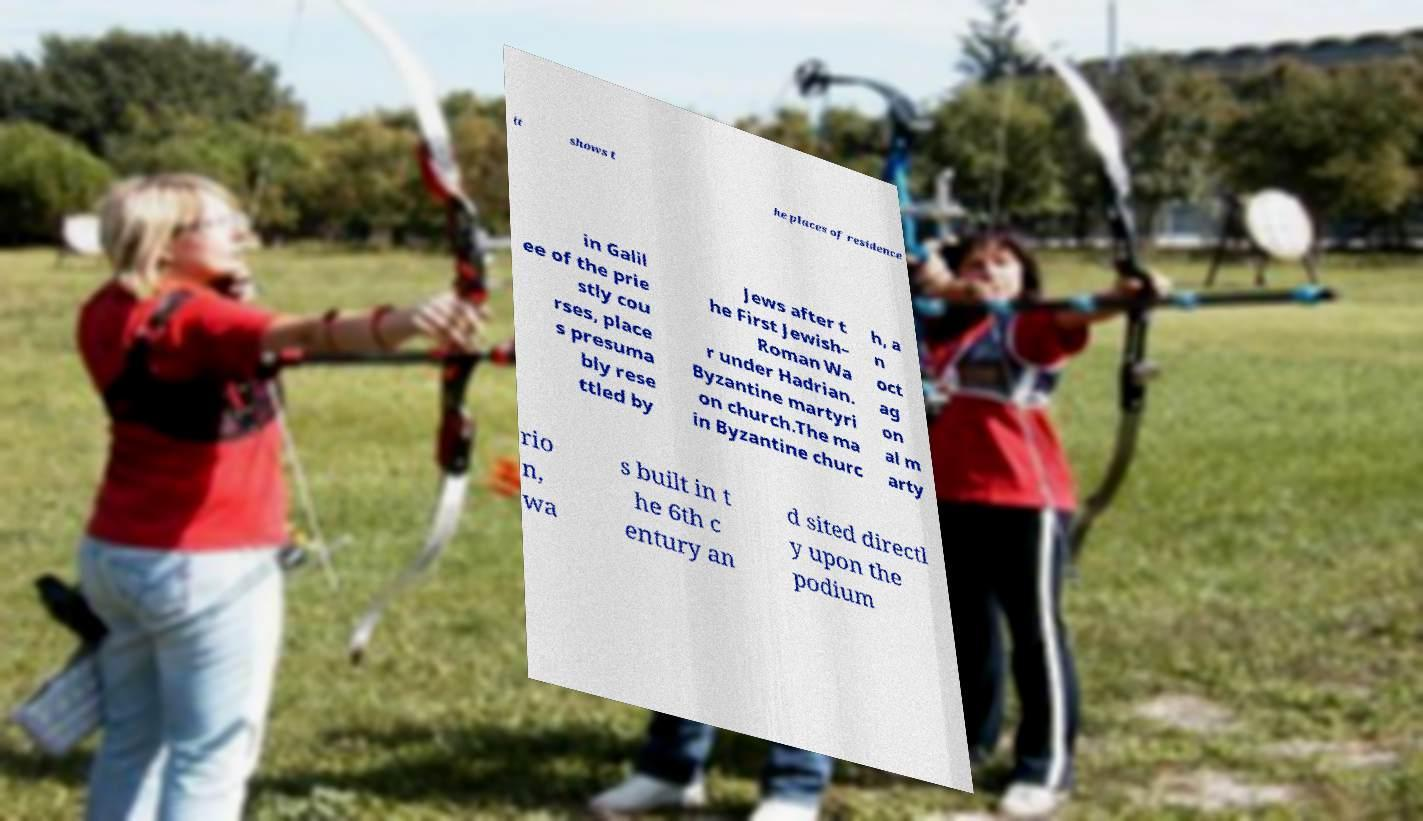For documentation purposes, I need the text within this image transcribed. Could you provide that? it shows t he places of residence in Galil ee of the prie stly cou rses, place s presuma bly rese ttled by Jews after t he First Jewish– Roman Wa r under Hadrian. Byzantine martyri on church.The ma in Byzantine churc h, a n oct ag on al m arty rio n, wa s built in t he 6th c entury an d sited directl y upon the podium 